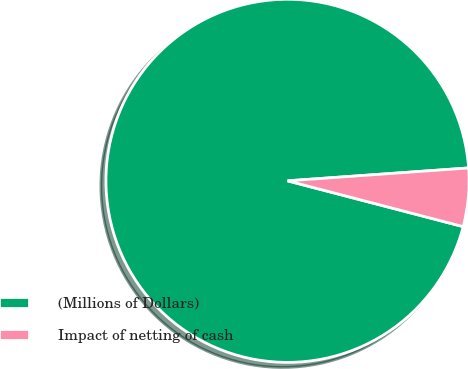<chart> <loc_0><loc_0><loc_500><loc_500><pie_chart><fcel>(Millions of Dollars)<fcel>Impact of netting of cash<nl><fcel>94.81%<fcel>5.19%<nl></chart> 